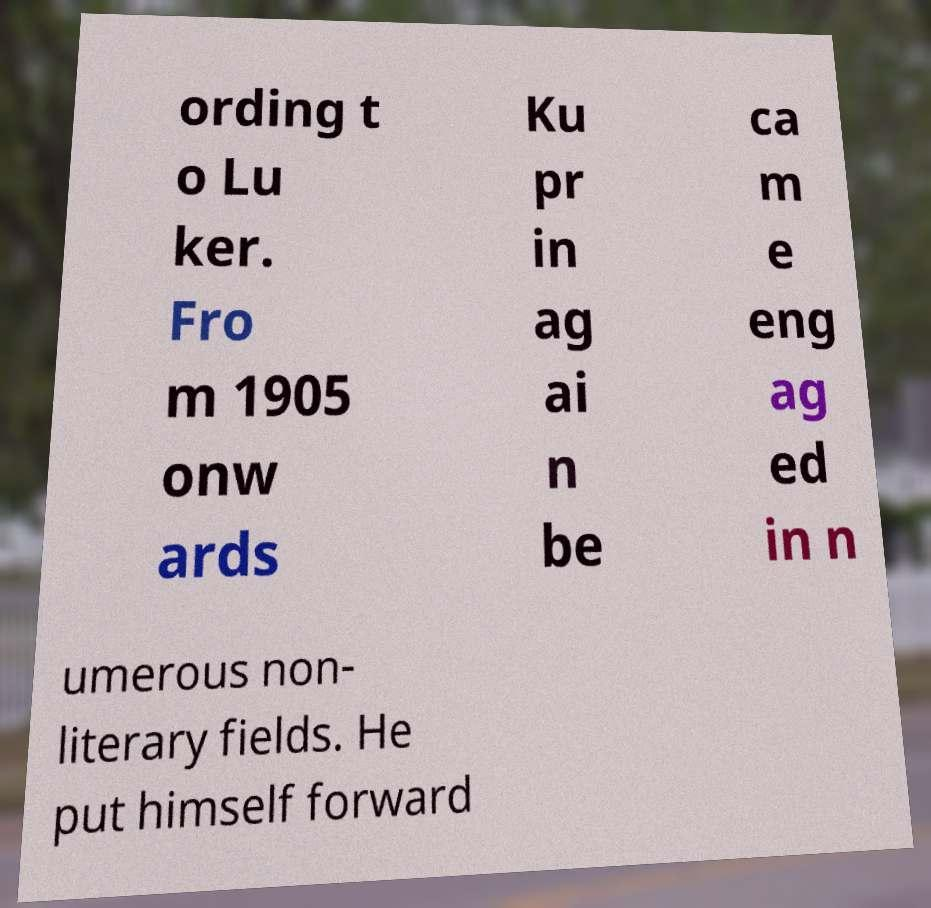Could you extract and type out the text from this image? ording t o Lu ker. Fro m 1905 onw ards Ku pr in ag ai n be ca m e eng ag ed in n umerous non- literary fields. He put himself forward 